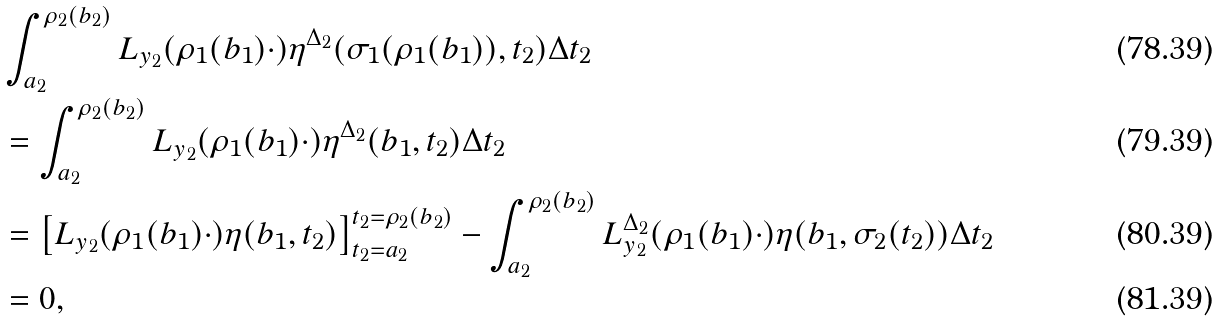Convert formula to latex. <formula><loc_0><loc_0><loc_500><loc_500>& \int _ { a _ { 2 } } ^ { \rho _ { 2 } ( b _ { 2 } ) } L _ { y _ { 2 } } ( \rho _ { 1 } ( b _ { 1 } ) \cdot ) \eta ^ { \Delta _ { 2 } } ( \sigma _ { 1 } ( \rho _ { 1 } ( b _ { 1 } ) ) , t _ { 2 } ) \Delta t _ { 2 } \\ & = \int _ { a _ { 2 } } ^ { \rho _ { 2 } ( b _ { 2 } ) } L _ { y _ { 2 } } ( \rho _ { 1 } ( b _ { 1 } ) \cdot ) \eta ^ { \Delta _ { 2 } } ( b _ { 1 } , t _ { 2 } ) \Delta t _ { 2 } \\ & = \left [ L _ { y _ { 2 } } ( \rho _ { 1 } ( b _ { 1 } ) \cdot ) \eta ( b _ { 1 } , t _ { 2 } ) \right ] _ { t _ { 2 } = a _ { 2 } } ^ { t _ { 2 } = \rho _ { 2 } ( b _ { 2 } ) } - \int _ { a _ { 2 } } ^ { \rho _ { 2 } ( b _ { 2 } ) } L _ { y _ { 2 } } ^ { \Delta _ { 2 } } ( \rho _ { 1 } ( b _ { 1 } ) \cdot ) \eta ( b _ { 1 } , \sigma _ { 2 } ( t _ { 2 } ) ) \Delta t _ { 2 } \\ & = 0 ,</formula> 